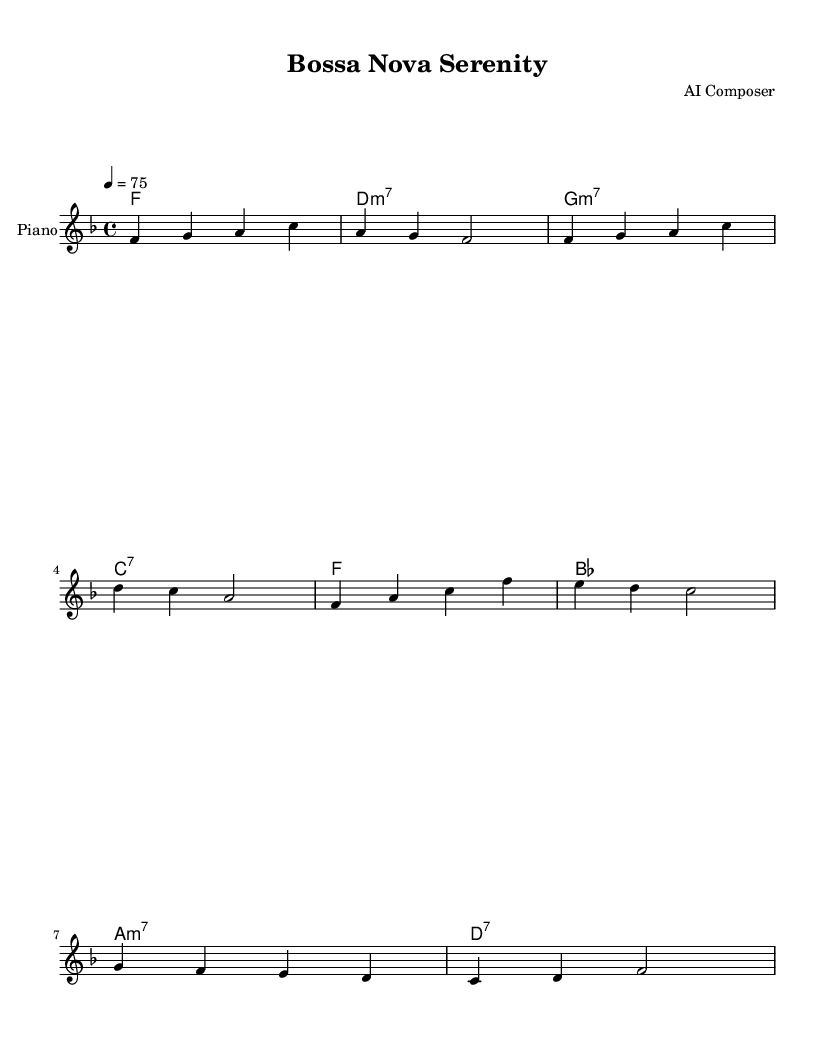What is the key signature of this music? The key signature is F major, which has one flat (B flat).
Answer: F major What is the time signature of this music? The time signature is 4/4, indicating four beats per measure.
Answer: 4/4 What is the tempo marking of the piece? The tempo marking indicates a speed of 75 beats per minute, which suggests a moderate pace.
Answer: 75 What is the first chord in the harmonies? The first chord listed is F major, which provides a stable tonal center for the piece.
Answer: F How many measures are in the melody section? The melody section consists of eight measures, as each line typically represents one full measure in 4/4 time.
Answer: 8 What type of seventh chord is used in the second measure of harmonies? The second measure contains a D minor seventh chord, indicated by the "m7" symbol next to "D."
Answer: D:m7 Which instrument is specified to perform the melody? The melody is intended to be played on the piano, as indicated by the instrument name in the score.
Answer: Piano 